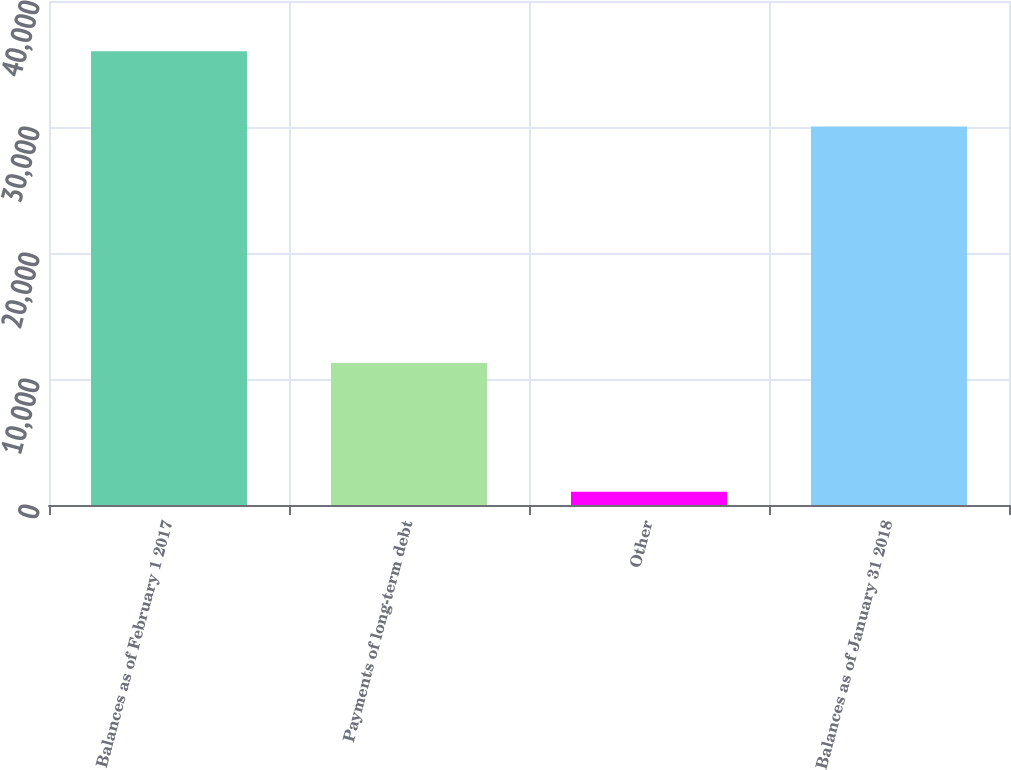<chart> <loc_0><loc_0><loc_500><loc_500><bar_chart><fcel>Balances as of February 1 2017<fcel>Payments of long-term debt<fcel>Other<fcel>Balances as of January 31 2018<nl><fcel>36015<fcel>11272<fcel>1050<fcel>30045<nl></chart> 